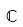Convert formula to latex. <formula><loc_0><loc_0><loc_500><loc_500>\mathbb { C }</formula> 